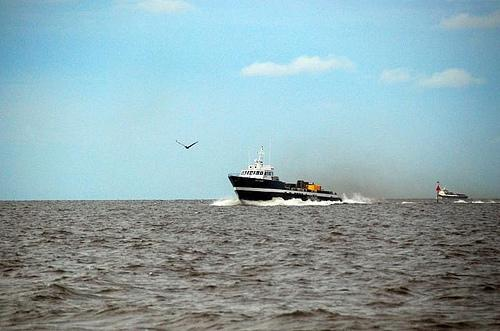What is the boat plowing through?

Choices:
A) lake
B) ocean
C) canal
D) riverwater ocean 